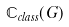<formula> <loc_0><loc_0><loc_500><loc_500>\mathbb { C } _ { c l a s s } ( G )</formula> 